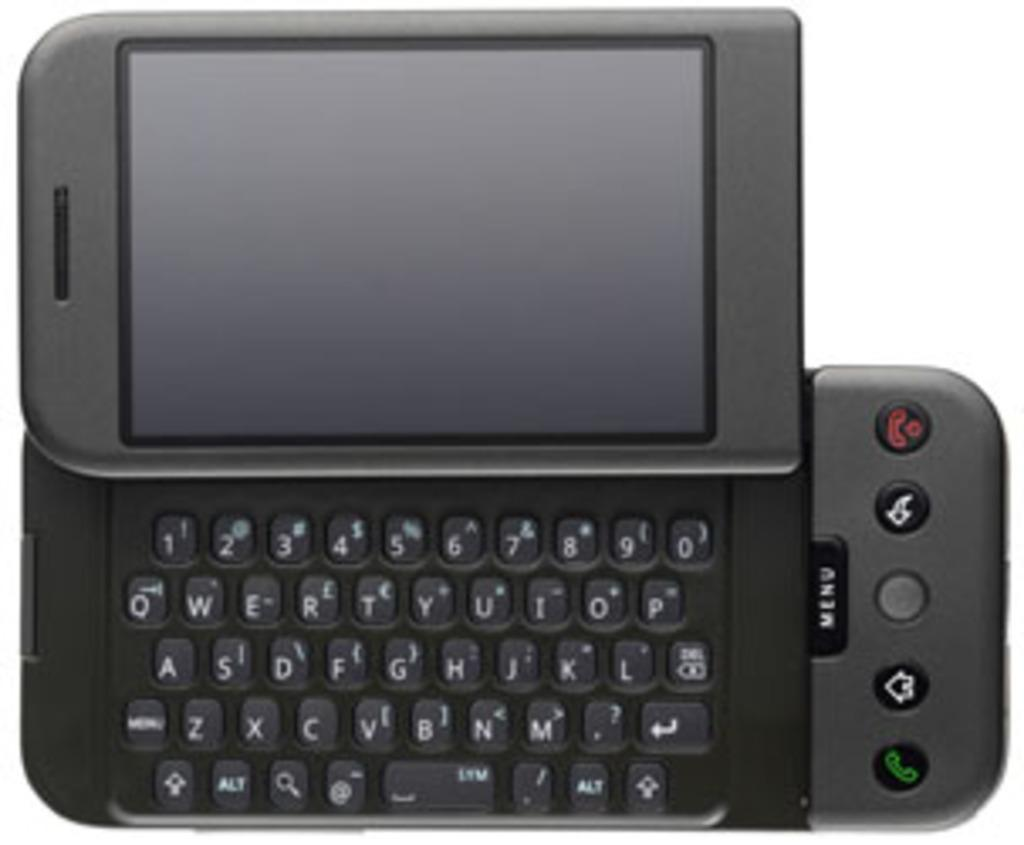<image>
Offer a succinct explanation of the picture presented. A blackberry with a slider QWERTY keyboard is on display. 